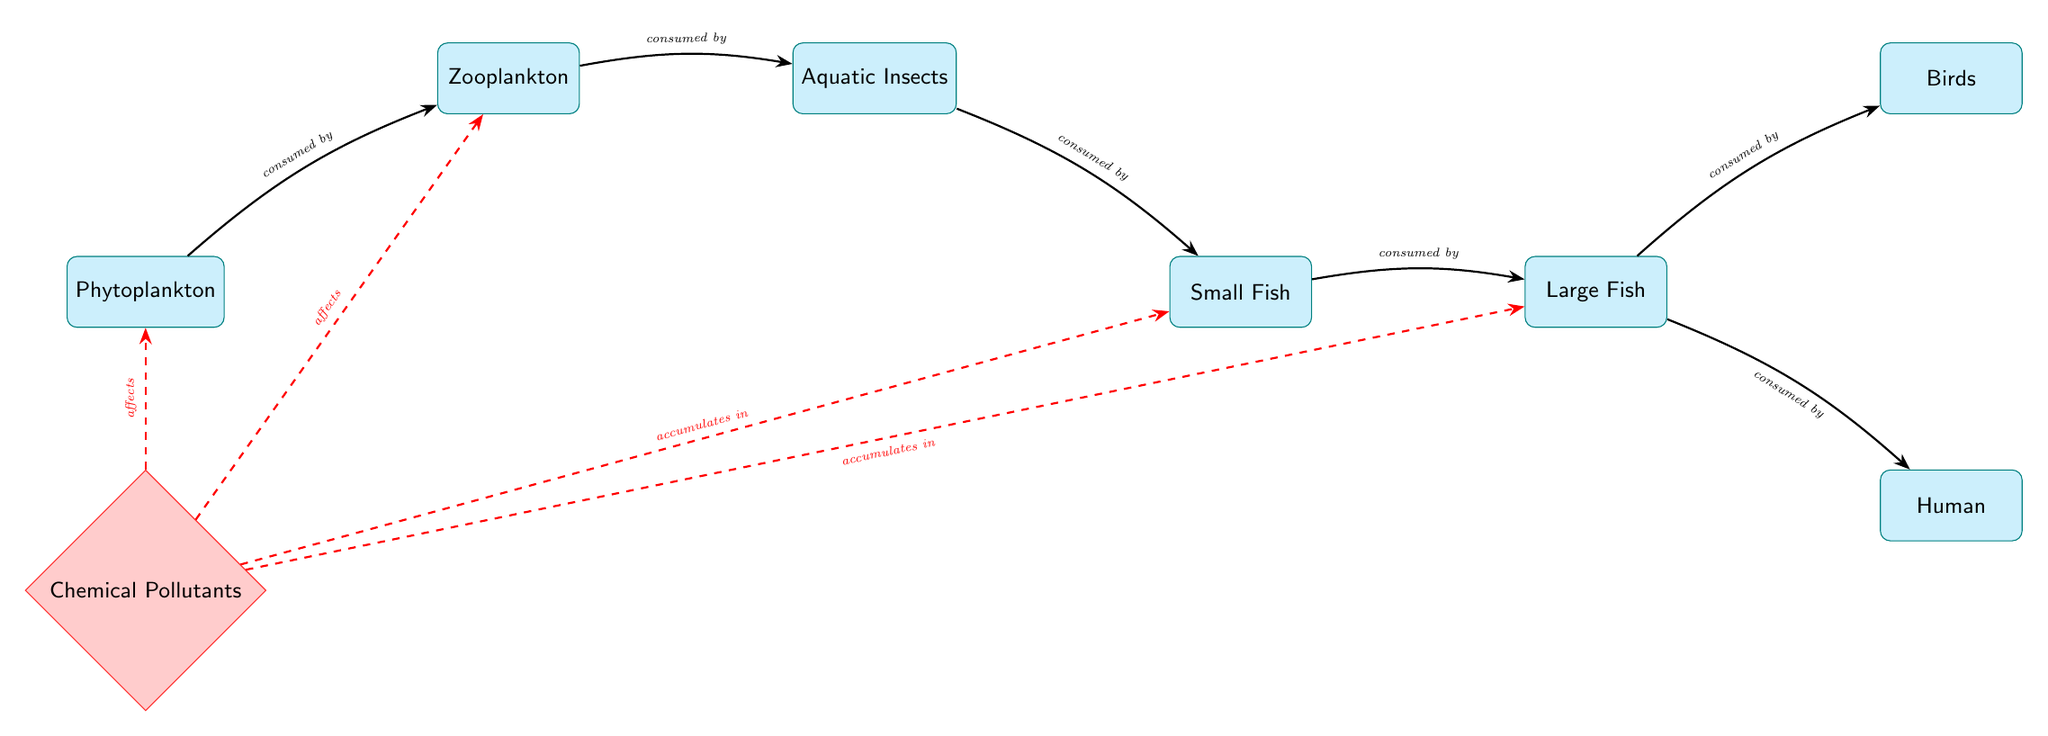What is the first node in the food chain? The diagram shows the flow of energy starting from phytoplankton as the primary producers at the top of the food chain. Therefore, the first node is identified as phytoplankton.
Answer: phytoplankton How many nodes are represented in the diagram? By counting the individual species and pollutants connected in the diagram, we find a total of 7 nodes: phytoplankton, zooplankton, aquatic insects, small fish, large fish, birds, and human, as well as 1 pollutant node. Therefore, there are 8 nodes.
Answer: 8 Which organisms are affected by chemical pollutants? The diagram indicates that chemical pollutants affect phytoplankton and zooplankton directly and accumulates in small fish and large fish. Thus, the affected organisms include phytoplankton, zooplankton, small fish, and large fish.
Answer: phytoplankton, zooplankton, small fish, large fish What is the relationship between zooplankton and aquatic insects? The diagram illustrates a direct relationship where zooplankton is consumed by aquatic insects, demonstrating a predatory relationship in the food chain.
Answer: consumed by Which organism sits at the top of the food chain? In the hierarchy of the food chain represented in the diagram, the large fish and birds consume small fish, placing them at the top when considering birds above large fish. Thus, the top organism is identified as birds.
Answer: birds How do chemical pollutants reach large fish? The diagram outlines that chemical pollutants affect phytoplankton and zooplankton, which are consumed by small fish. These small fish, in turn, are consumed by large fish, resulting in the accumulation of pollutants in them. Therefore, the route for pollutants is through phytoplankton to zooplankton, then to small fish, and finally to large fish.
Answer: through food chain What can accumulate in small fish due to pollution? According to the diagram, chemical pollutants specifically accumulate in small fish, indicating an adverse effect of pollution on aquatic life.
Answer: chemical pollutants What type of edge connects the pollutants to the nodes? The edges from the chemical pollutants to phytoplankton and zooplankton are dashed and red, indicating that these edges represent the adverse effects of pollutants rather than a standard consumptive relationship.
Answer: dashed and red How many relationships are indicated between large fish and other nodes? In the food chain presented, large fish are consumed by both birds and humans, indicating two outgoing relationships. Hence, the total number of relationships indicated between large fish and other nodes is 2.
Answer: 2 